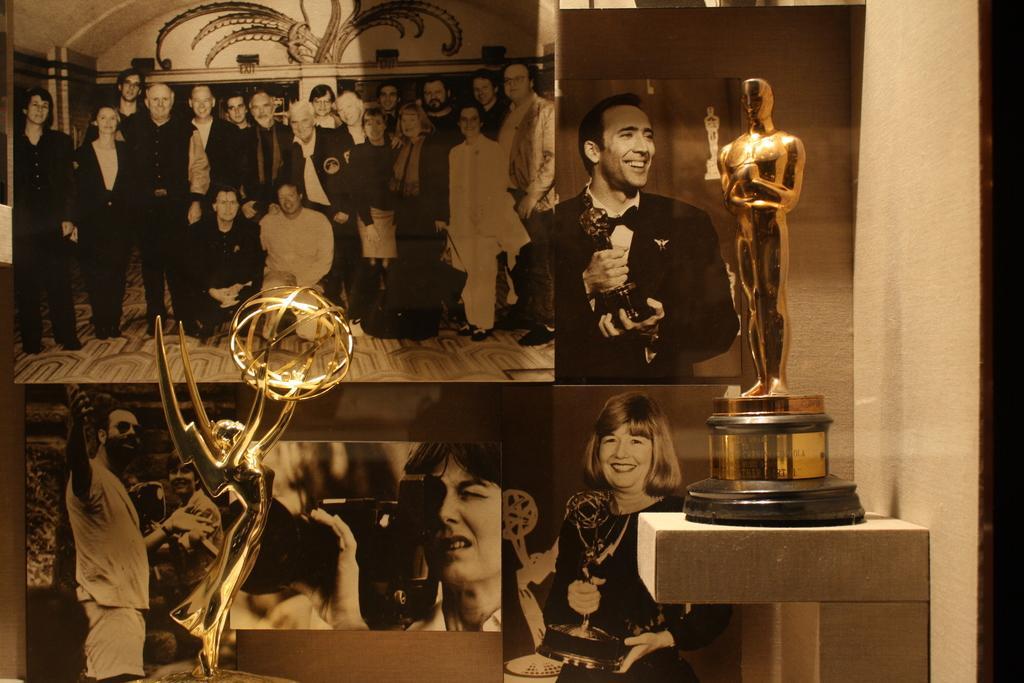In one or two sentences, can you explain what this image depicts? In the foreground of the image we can see two trophies placed on stands. In the background, we can see a group of photos pasted on the wall. 